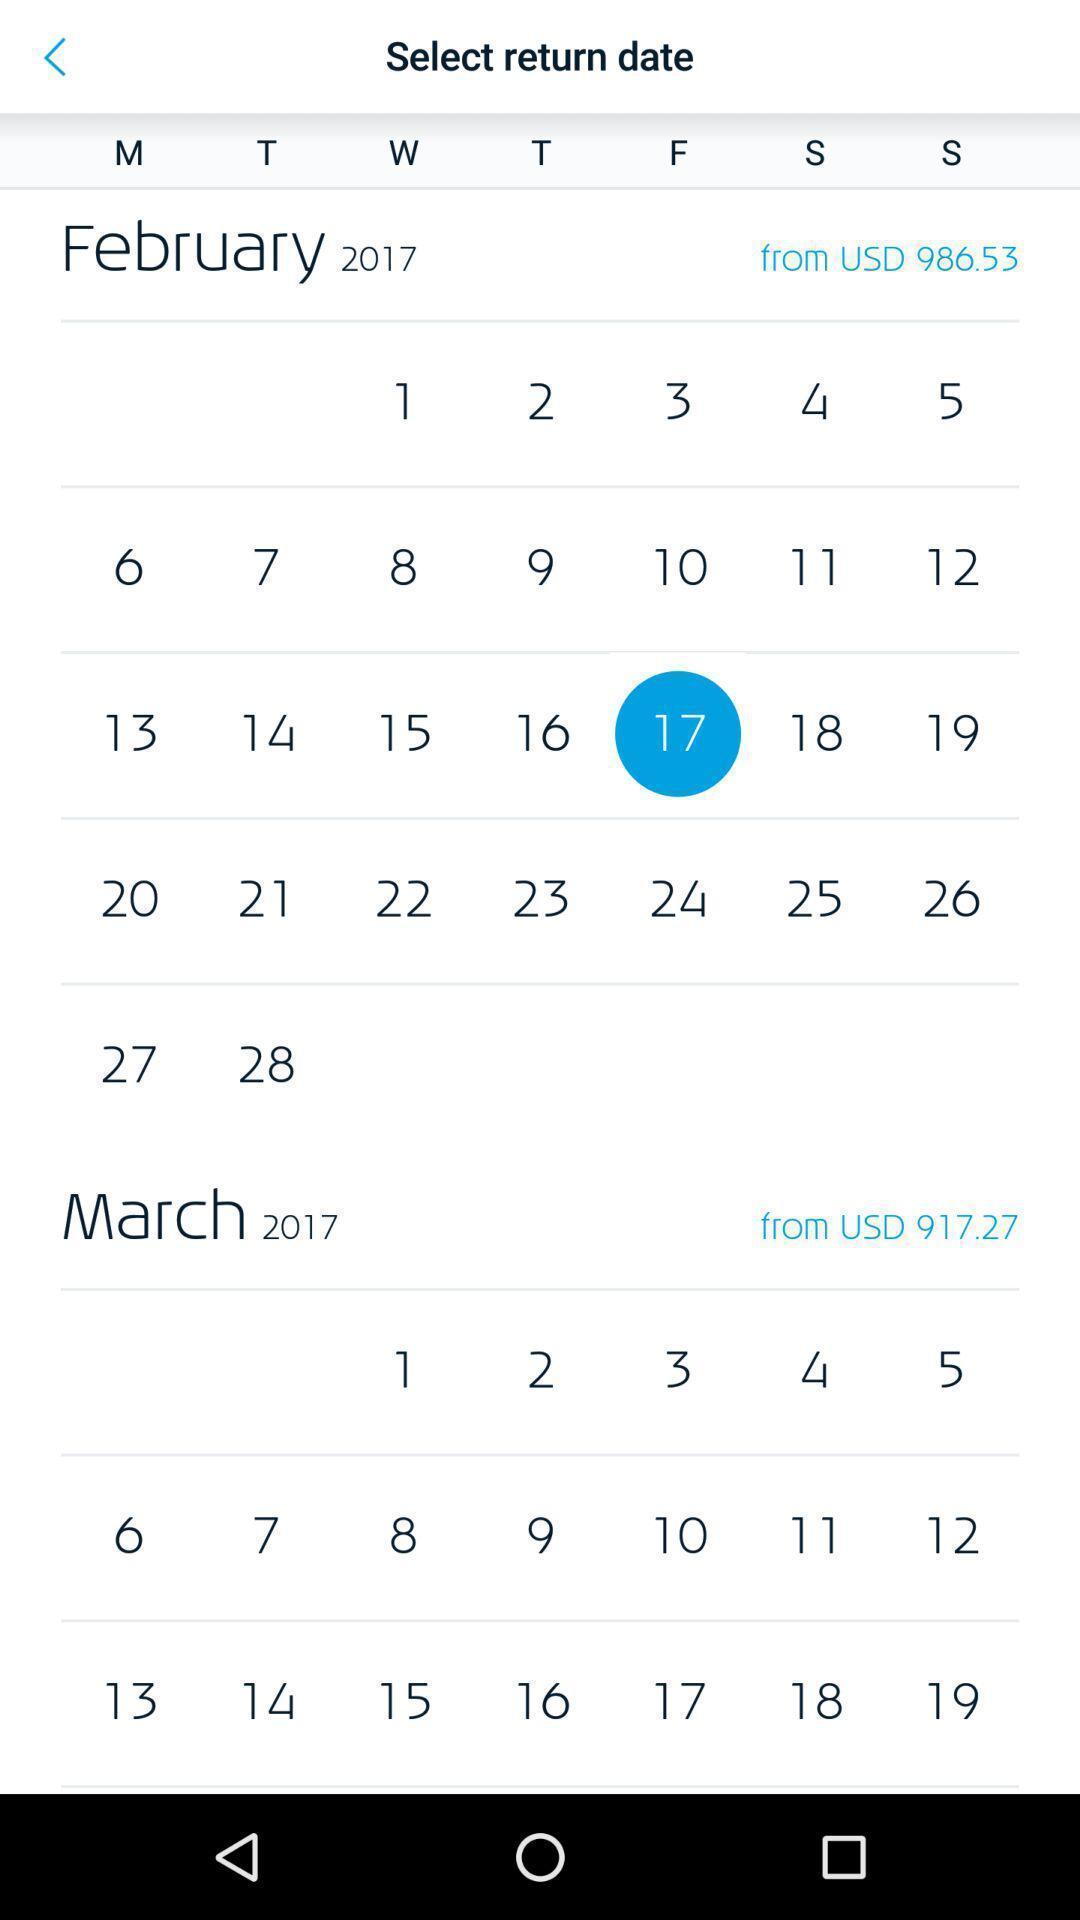Describe the key features of this screenshot. Screen displaying contents of calendar. 